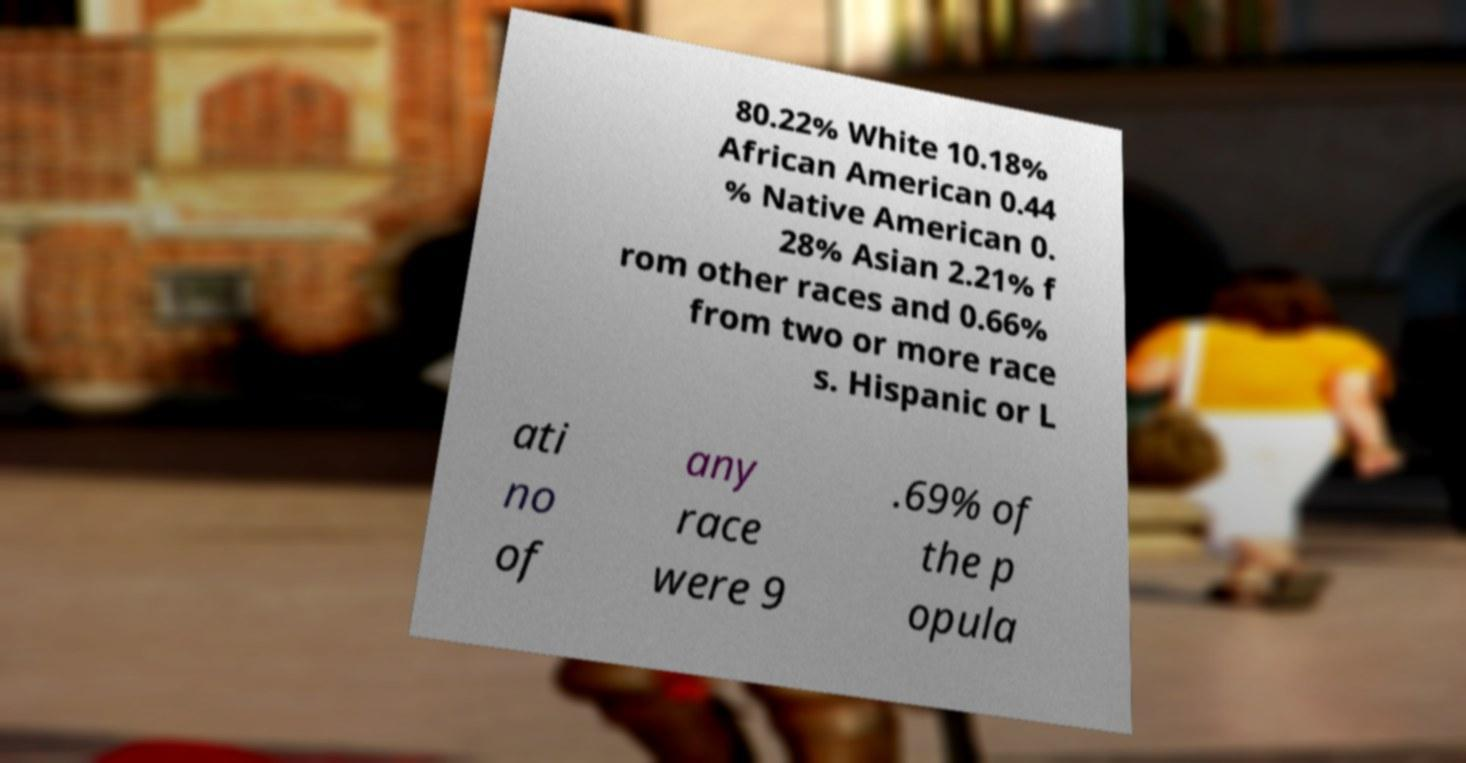What messages or text are displayed in this image? I need them in a readable, typed format. 80.22% White 10.18% African American 0.44 % Native American 0. 28% Asian 2.21% f rom other races and 0.66% from two or more race s. Hispanic or L ati no of any race were 9 .69% of the p opula 